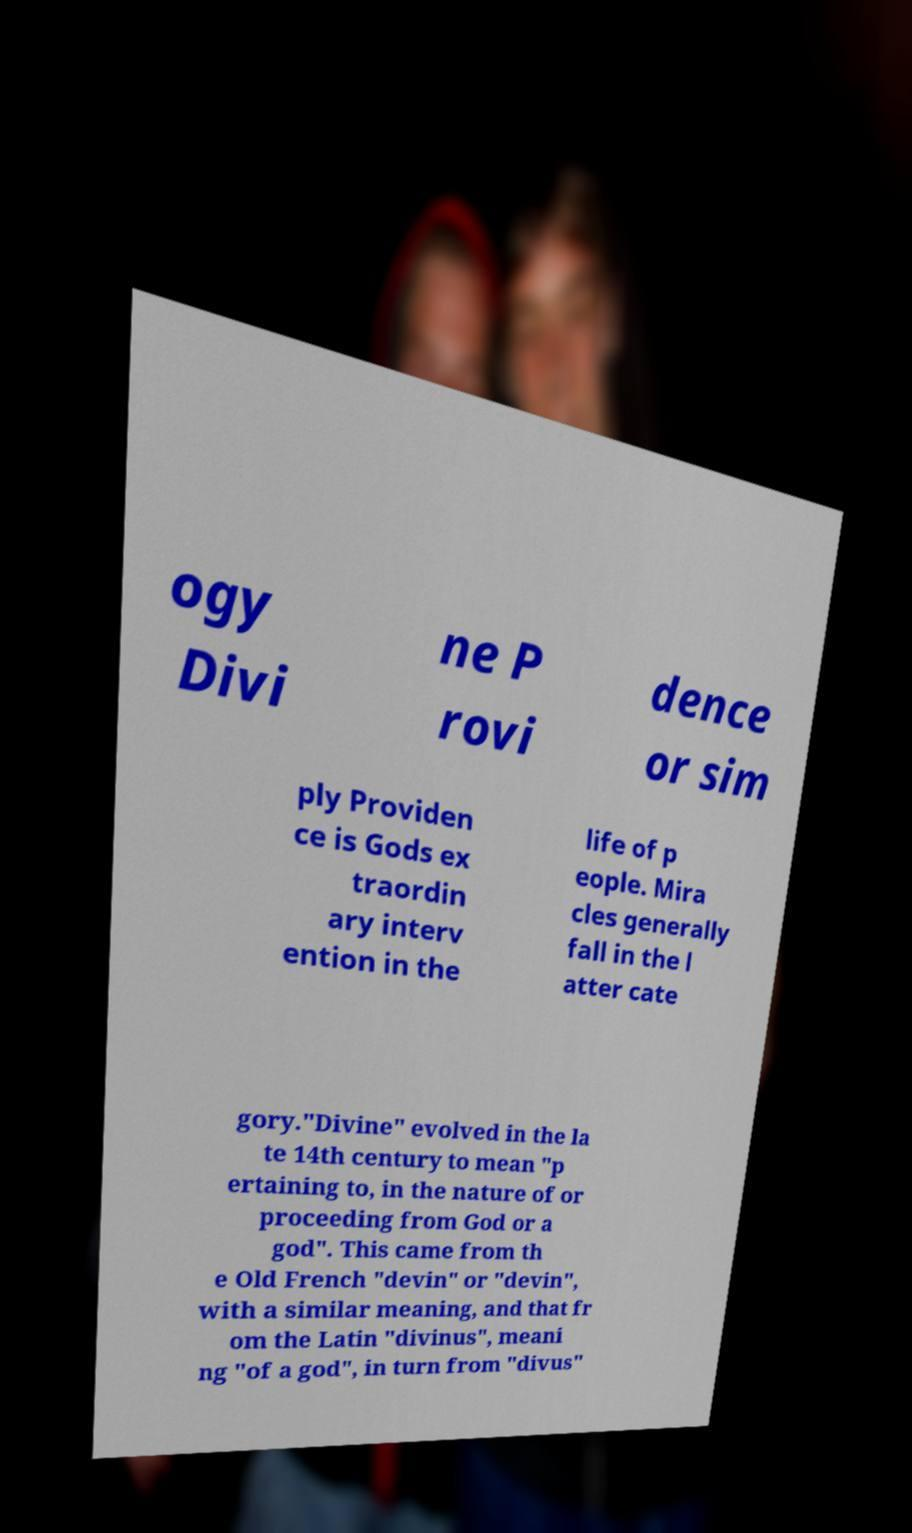I need the written content from this picture converted into text. Can you do that? ogy Divi ne P rovi dence or sim ply Providen ce is Gods ex traordin ary interv ention in the life of p eople. Mira cles generally fall in the l atter cate gory."Divine" evolved in the la te 14th century to mean "p ertaining to, in the nature of or proceeding from God or a god". This came from th e Old French "devin" or "devin", with a similar meaning, and that fr om the Latin "divinus", meani ng "of a god", in turn from "divus" 